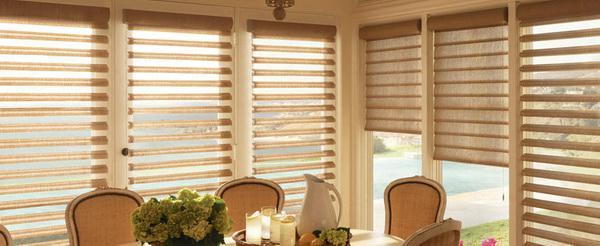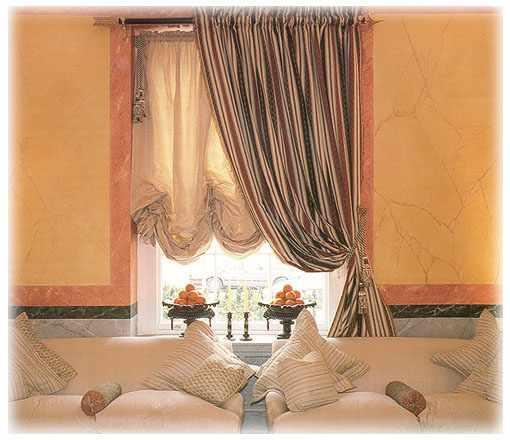The first image is the image on the left, the second image is the image on the right. Considering the images on both sides, is "In the image to the left, some chairs are visible in front of the window." valid? Answer yes or no. Yes. The first image is the image on the left, the second image is the image on the right. Analyze the images presented: Is the assertion "There are three blinds." valid? Answer yes or no. No. 